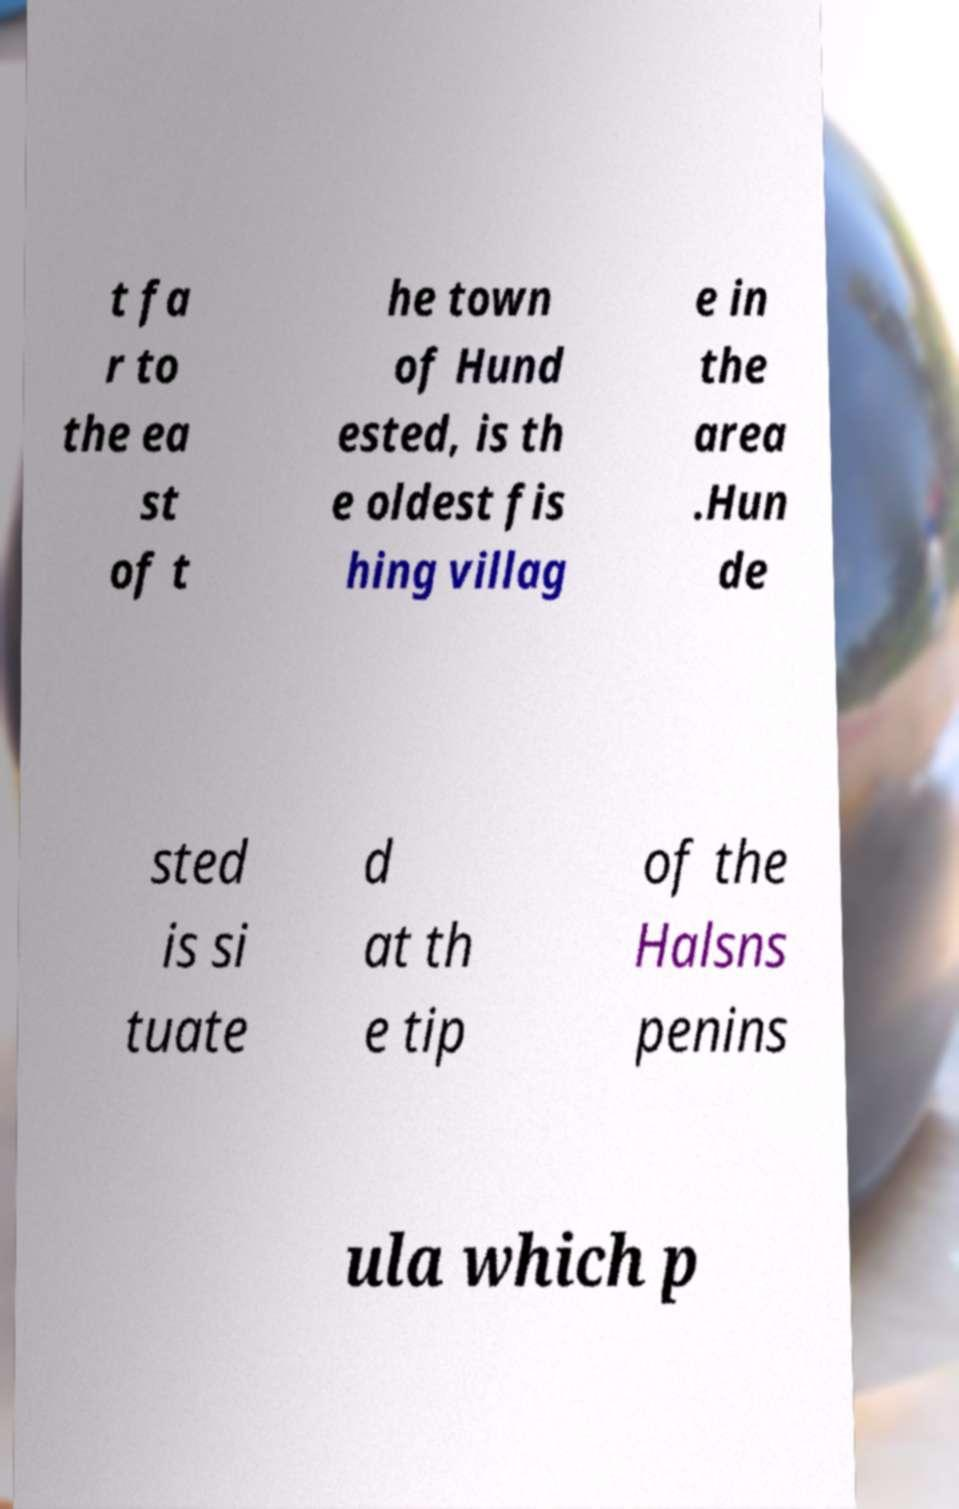Please read and relay the text visible in this image. What does it say? t fa r to the ea st of t he town of Hund ested, is th e oldest fis hing villag e in the area .Hun de sted is si tuate d at th e tip of the Halsns penins ula which p 